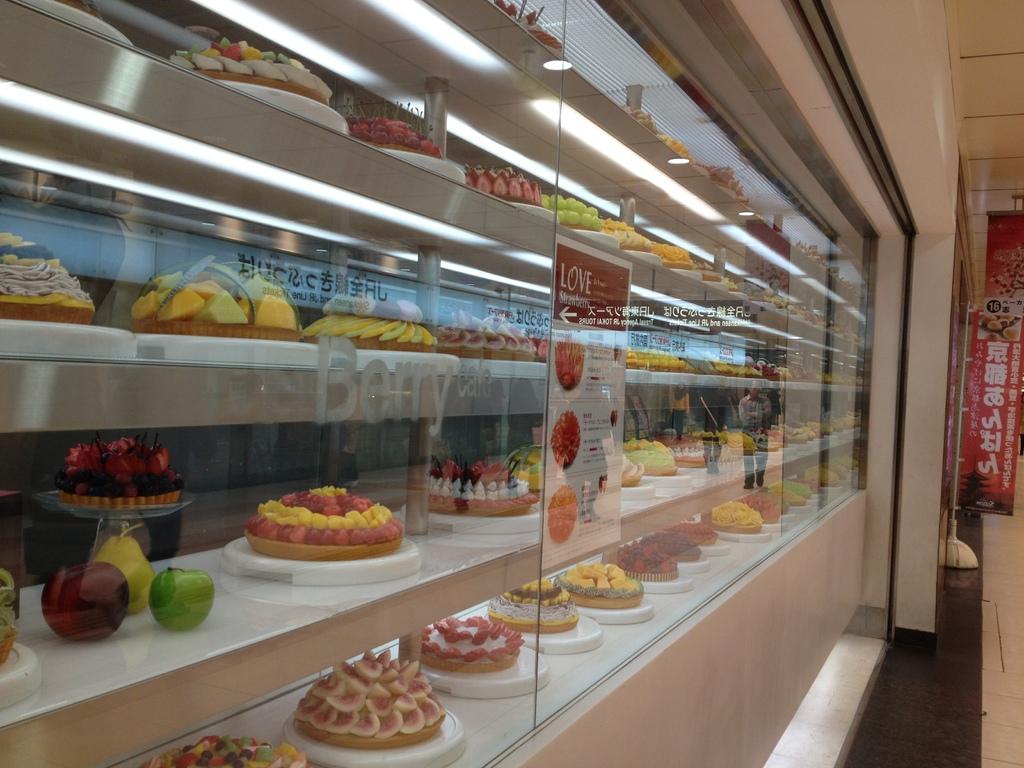What emotion is written on the sign?
Give a very brief answer. Love. What fruit is etched onto the glass?
Keep it short and to the point. Berry. 